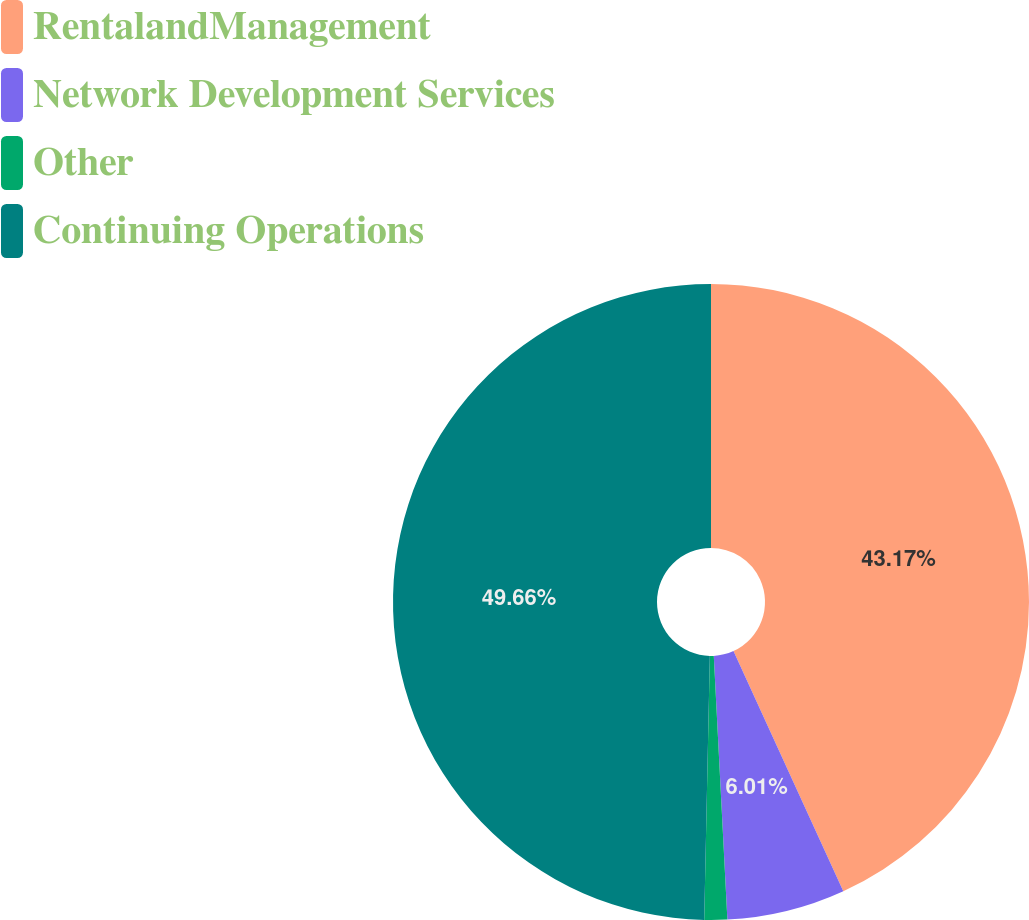Convert chart. <chart><loc_0><loc_0><loc_500><loc_500><pie_chart><fcel>RentalandManagement<fcel>Network Development Services<fcel>Other<fcel>Continuing Operations<nl><fcel>43.17%<fcel>6.01%<fcel>1.16%<fcel>49.66%<nl></chart> 